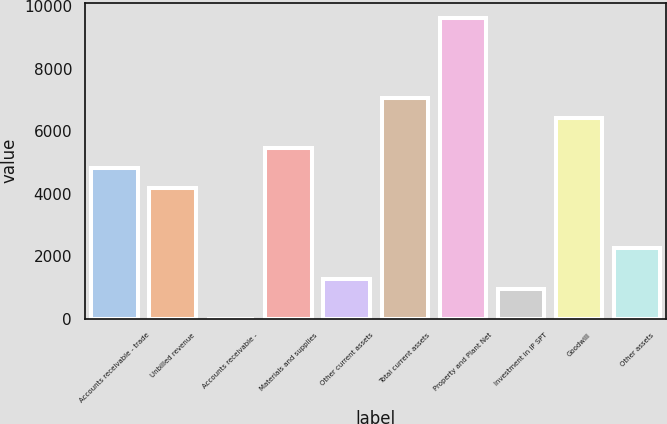Convert chart to OTSL. <chart><loc_0><loc_0><loc_500><loc_500><bar_chart><fcel>Accounts receivable - trade<fcel>Unbilled revenue<fcel>Accounts receivable -<fcel>Materials and supplies<fcel>Other current assets<fcel>Total current assets<fcel>Property and Plant Net<fcel>Investment in IP SPT<fcel>Goodwill<fcel>Other assets<nl><fcel>4817.5<fcel>4175.3<fcel>1<fcel>5459.7<fcel>1285.4<fcel>7065.2<fcel>9634<fcel>964.3<fcel>6423<fcel>2248.7<nl></chart> 